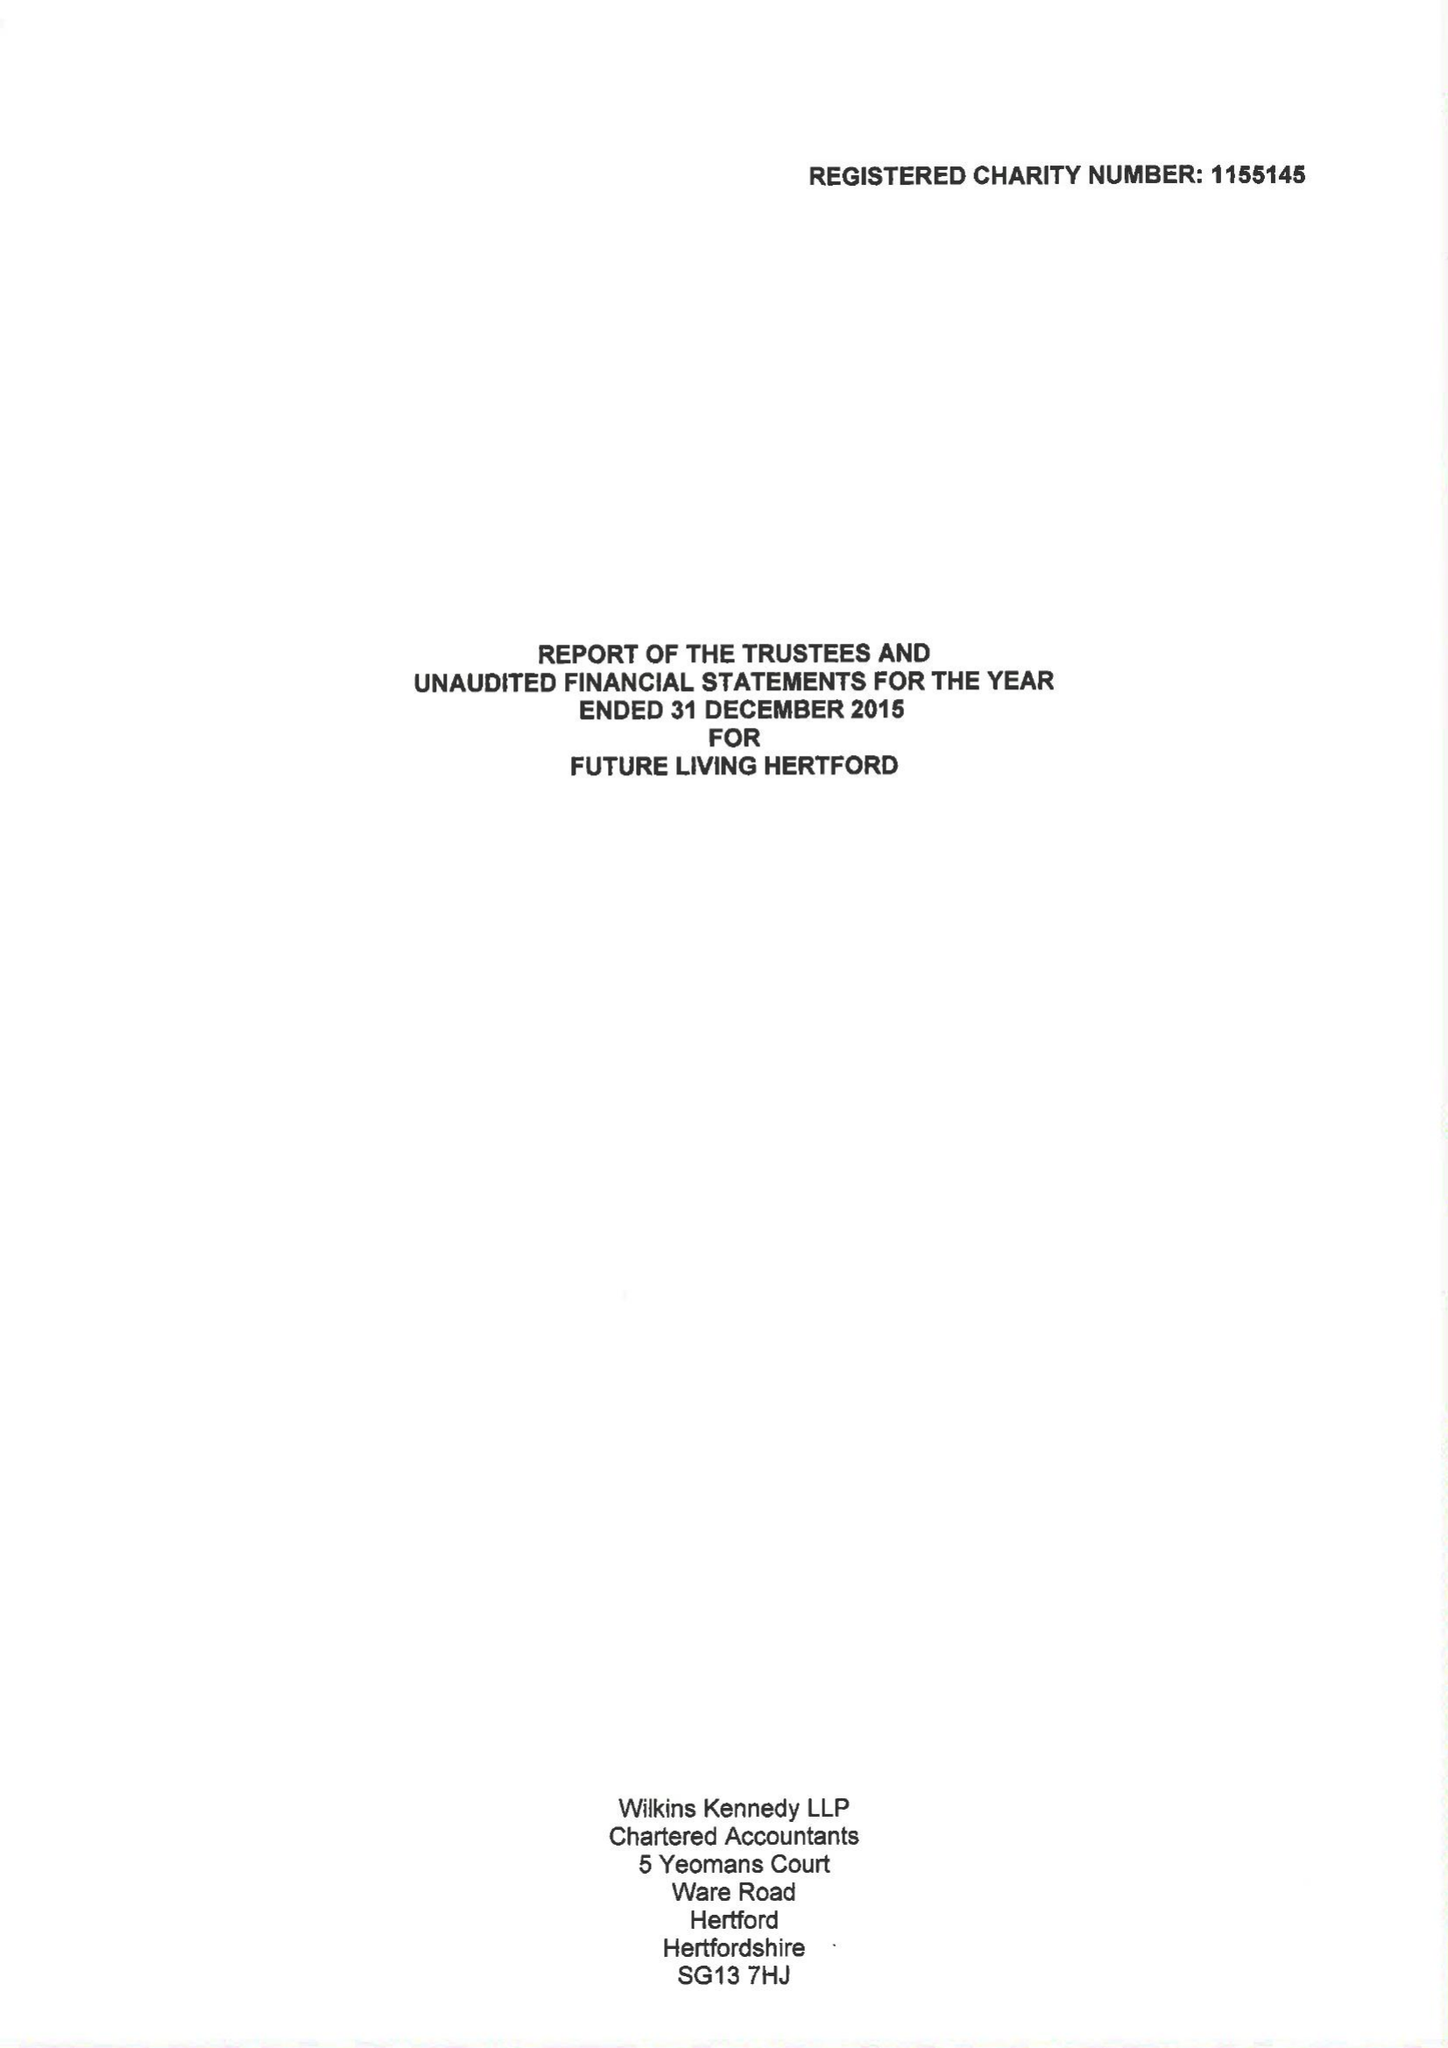What is the value for the address__postcode?
Answer the question using a single word or phrase. SG14 1PN 